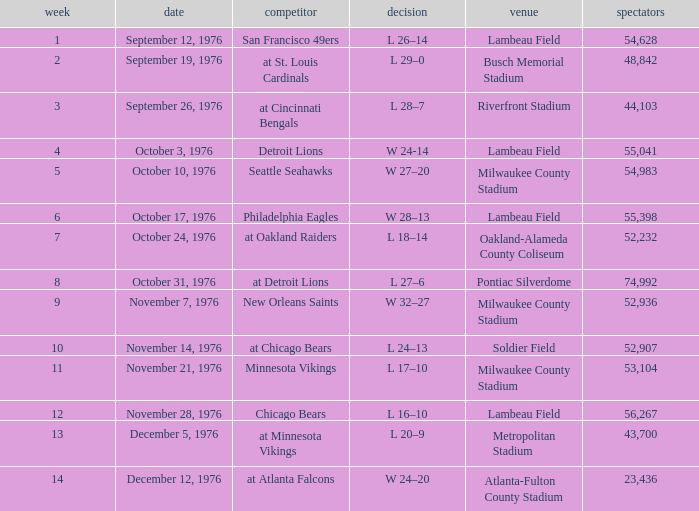What is the average attendance for the game on September 26, 1976? 44103.0. 